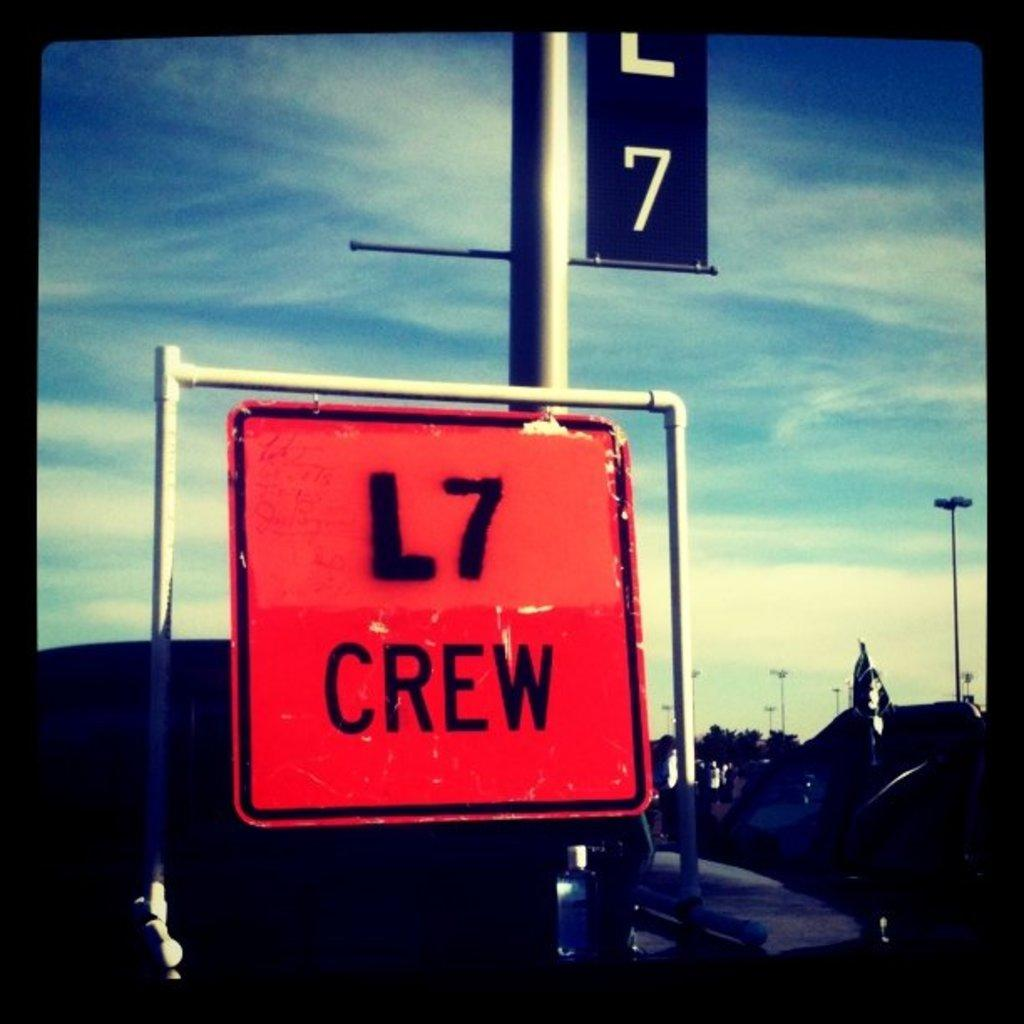<image>
Relay a brief, clear account of the picture shown. a square red sign with the word  L7 crew on it 